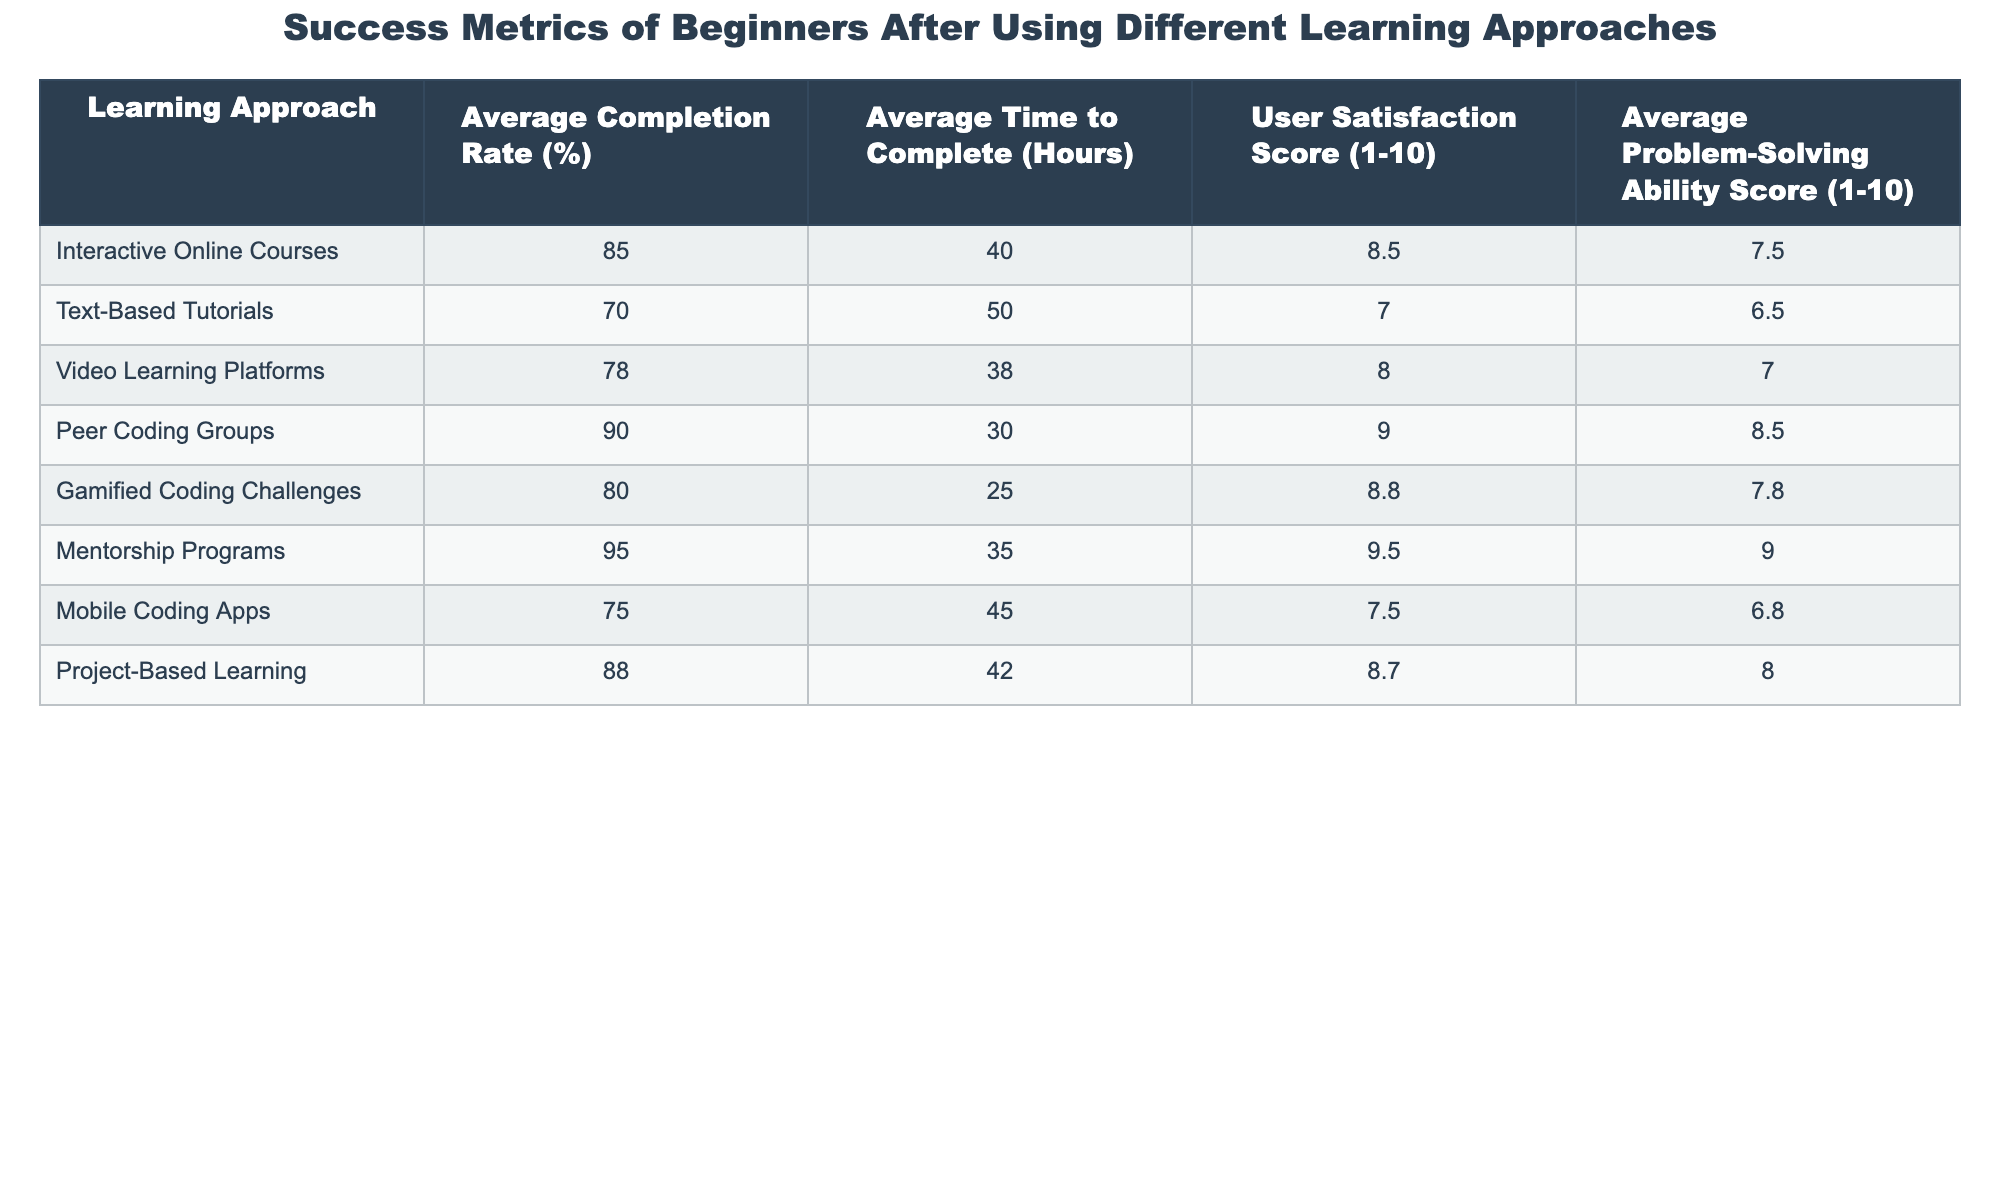What is the highest average user satisfaction score among the learning approaches? The user satisfaction scores for each approach are listed in the table. The highest score is 9.5 for Mentorship Programs.
Answer: 9.5 Which learning approach has the lowest average completion rate? The average completion rates for each learning approach are listed. The lowest completion rate is 70% for Text-Based Tutorials.
Answer: 70% What is the average completion rate of Project-Based Learning and Gamified Coding Challenges combined? The completion rates for both approaches are 88% and 80%, respectively. Adding them gives 88 + 80 = 168, and dividing by 2 results in an average of 168/2 = 84%.
Answer: 84% Do Peer Coding Groups have a higher average problem-solving ability score than Video Learning Platforms? Peer Coding Groups have a problem-solving score of 8.5, whereas Video Learning Platforms have a score of 7.0. Since 8.5 is greater than 7.0, the answer is yes.
Answer: Yes What is the difference in average time to complete between Mentorship Programs and Mobile Coding Apps? Mentorship Programs take 35 hours to complete, and Mobile Coding Apps take 45 hours. The difference is 45 - 35 = 10 hours.
Answer: 10 hours Which learning approach has the best combination of user satisfaction score and completion rate? Evaluating the approaches shows that Mentorship Programs have the highest user satisfaction score (9.5) and the highest completion rate (95%). This combination is the best of all approaches.
Answer: Mentorship Programs How does the average time to complete for Interactive Online Courses compare to that of Gamified Coding Challenges? Interactive Online Courses take 40 hours, while Gamified Coding Challenges take 25 hours. The difference is thus 40 - 25 = 15 hours, indicating that Interactive Online Courses require more time.
Answer: 15 hours What is the overall average user satisfaction score across all learning approaches? Adding together all user satisfaction scores (8.5 + 7.0 + 8.0 + 9.0 + 8.8 + 9.5 + 7.5 + 8.7 = 68.5) and dividing by the number of approaches (8) gives an average of 68.5/8 = 8.56.
Answer: 8.56 Is the average time to complete for Text-Based Tutorials greater than the overall average time to complete across all approaches? Text-Based Tutorials take 50 hours. The overall average time (calculating all time values, totaling 40+50+38+30+25+35+45+42 = 305 hours; dividing by 8 gives 305/8 = 38.125) is 38.125 hours. Since 50 is greater than 38.125, the answer is yes.
Answer: Yes What percentage of problem-solving ability scores are higher than 8 for the recorded approaches? The scores higher than 8 are listed as 8.5 (Peer Coding Groups), 9.0 (Mentorship Programs), and 8.7 (Project-Based Learning). There are 3 approaches with scores above 8 out of 8 total approaches, resulting in (3/8)*100 = 37.5%.
Answer: 37.5% 